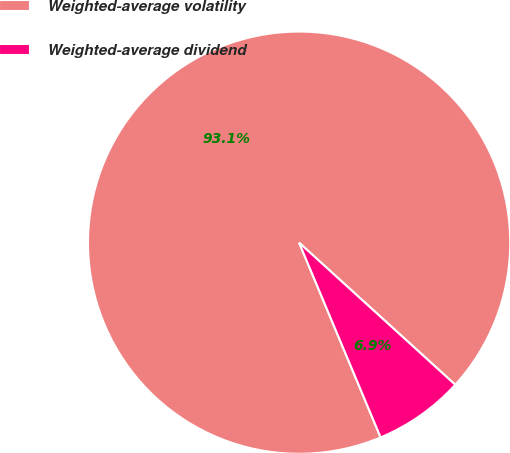Convert chart to OTSL. <chart><loc_0><loc_0><loc_500><loc_500><pie_chart><fcel>Weighted-average volatility<fcel>Weighted-average dividend<nl><fcel>93.06%<fcel>6.94%<nl></chart> 